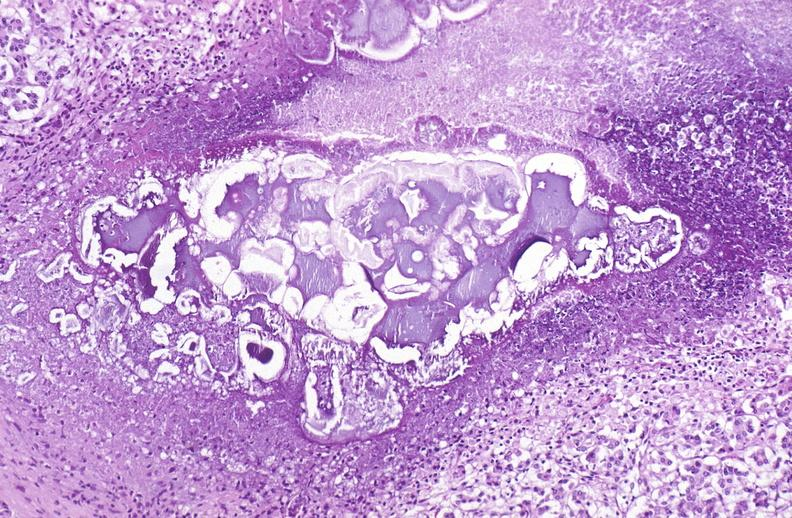does pneumocystis show pancreatic fat necrosis?
Answer the question using a single word or phrase. No 